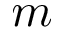Convert formula to latex. <formula><loc_0><loc_0><loc_500><loc_500>m</formula> 